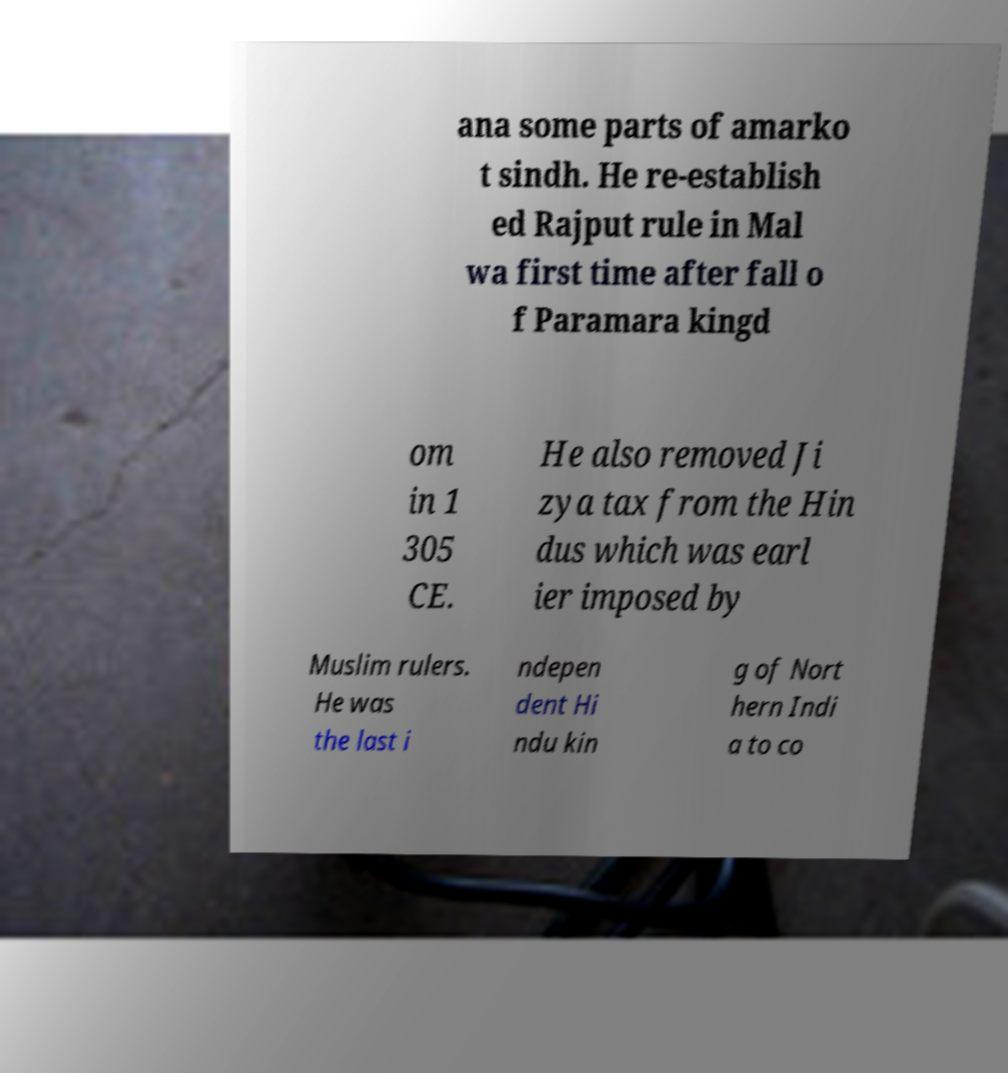I need the written content from this picture converted into text. Can you do that? ana some parts of amarko t sindh. He re-establish ed Rajput rule in Mal wa first time after fall o f Paramara kingd om in 1 305 CE. He also removed Ji zya tax from the Hin dus which was earl ier imposed by Muslim rulers. He was the last i ndepen dent Hi ndu kin g of Nort hern Indi a to co 